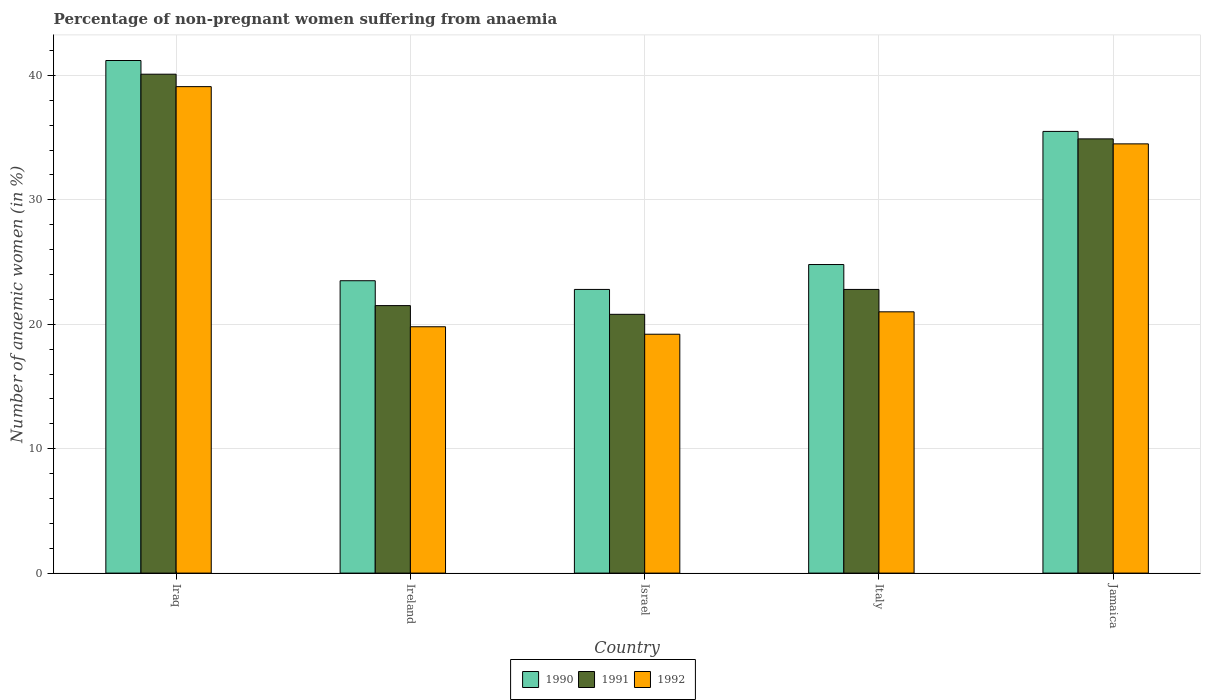How many different coloured bars are there?
Make the answer very short. 3. How many groups of bars are there?
Your answer should be compact. 5. Are the number of bars on each tick of the X-axis equal?
Keep it short and to the point. Yes. How many bars are there on the 1st tick from the left?
Provide a succinct answer. 3. What is the label of the 1st group of bars from the left?
Keep it short and to the point. Iraq. In how many cases, is the number of bars for a given country not equal to the number of legend labels?
Keep it short and to the point. 0. What is the percentage of non-pregnant women suffering from anaemia in 1991 in Israel?
Keep it short and to the point. 20.8. Across all countries, what is the maximum percentage of non-pregnant women suffering from anaemia in 1992?
Make the answer very short. 39.1. Across all countries, what is the minimum percentage of non-pregnant women suffering from anaemia in 1990?
Keep it short and to the point. 22.8. In which country was the percentage of non-pregnant women suffering from anaemia in 1991 maximum?
Your answer should be very brief. Iraq. In which country was the percentage of non-pregnant women suffering from anaemia in 1990 minimum?
Provide a short and direct response. Israel. What is the total percentage of non-pregnant women suffering from anaemia in 1992 in the graph?
Keep it short and to the point. 133.6. What is the difference between the percentage of non-pregnant women suffering from anaemia in 1992 in Iraq and that in Ireland?
Your answer should be very brief. 19.3. What is the difference between the percentage of non-pregnant women suffering from anaemia in 1992 in Israel and the percentage of non-pregnant women suffering from anaemia in 1990 in Italy?
Keep it short and to the point. -5.6. What is the average percentage of non-pregnant women suffering from anaemia in 1990 per country?
Provide a succinct answer. 29.56. What is the ratio of the percentage of non-pregnant women suffering from anaemia in 1990 in Ireland to that in Jamaica?
Offer a terse response. 0.66. Is the difference between the percentage of non-pregnant women suffering from anaemia in 1991 in Ireland and Italy greater than the difference between the percentage of non-pregnant women suffering from anaemia in 1992 in Ireland and Italy?
Offer a terse response. No. What is the difference between the highest and the second highest percentage of non-pregnant women suffering from anaemia in 1990?
Your answer should be very brief. -16.4. What is the difference between the highest and the lowest percentage of non-pregnant women suffering from anaemia in 1992?
Ensure brevity in your answer.  19.9. In how many countries, is the percentage of non-pregnant women suffering from anaemia in 1990 greater than the average percentage of non-pregnant women suffering from anaemia in 1990 taken over all countries?
Provide a succinct answer. 2. Is the sum of the percentage of non-pregnant women suffering from anaemia in 1991 in Israel and Jamaica greater than the maximum percentage of non-pregnant women suffering from anaemia in 1990 across all countries?
Provide a short and direct response. Yes. What does the 1st bar from the left in Iraq represents?
Ensure brevity in your answer.  1990. Is it the case that in every country, the sum of the percentage of non-pregnant women suffering from anaemia in 1991 and percentage of non-pregnant women suffering from anaemia in 1992 is greater than the percentage of non-pregnant women suffering from anaemia in 1990?
Your answer should be very brief. Yes. How many bars are there?
Your response must be concise. 15. Are all the bars in the graph horizontal?
Provide a short and direct response. No. Are the values on the major ticks of Y-axis written in scientific E-notation?
Offer a terse response. No. Does the graph contain any zero values?
Provide a succinct answer. No. Does the graph contain grids?
Your response must be concise. Yes. How many legend labels are there?
Offer a very short reply. 3. What is the title of the graph?
Give a very brief answer. Percentage of non-pregnant women suffering from anaemia. What is the label or title of the Y-axis?
Give a very brief answer. Number of anaemic women (in %). What is the Number of anaemic women (in %) of 1990 in Iraq?
Give a very brief answer. 41.2. What is the Number of anaemic women (in %) in 1991 in Iraq?
Offer a very short reply. 40.1. What is the Number of anaemic women (in %) of 1992 in Iraq?
Keep it short and to the point. 39.1. What is the Number of anaemic women (in %) in 1990 in Ireland?
Your response must be concise. 23.5. What is the Number of anaemic women (in %) in 1991 in Ireland?
Provide a short and direct response. 21.5. What is the Number of anaemic women (in %) in 1992 in Ireland?
Your answer should be compact. 19.8. What is the Number of anaemic women (in %) in 1990 in Israel?
Make the answer very short. 22.8. What is the Number of anaemic women (in %) of 1991 in Israel?
Ensure brevity in your answer.  20.8. What is the Number of anaemic women (in %) of 1992 in Israel?
Offer a very short reply. 19.2. What is the Number of anaemic women (in %) in 1990 in Italy?
Your response must be concise. 24.8. What is the Number of anaemic women (in %) of 1991 in Italy?
Ensure brevity in your answer.  22.8. What is the Number of anaemic women (in %) of 1990 in Jamaica?
Provide a succinct answer. 35.5. What is the Number of anaemic women (in %) of 1991 in Jamaica?
Offer a very short reply. 34.9. What is the Number of anaemic women (in %) in 1992 in Jamaica?
Provide a succinct answer. 34.5. Across all countries, what is the maximum Number of anaemic women (in %) of 1990?
Offer a very short reply. 41.2. Across all countries, what is the maximum Number of anaemic women (in %) in 1991?
Give a very brief answer. 40.1. Across all countries, what is the maximum Number of anaemic women (in %) in 1992?
Provide a succinct answer. 39.1. Across all countries, what is the minimum Number of anaemic women (in %) in 1990?
Keep it short and to the point. 22.8. Across all countries, what is the minimum Number of anaemic women (in %) in 1991?
Make the answer very short. 20.8. Across all countries, what is the minimum Number of anaemic women (in %) of 1992?
Provide a short and direct response. 19.2. What is the total Number of anaemic women (in %) of 1990 in the graph?
Make the answer very short. 147.8. What is the total Number of anaemic women (in %) in 1991 in the graph?
Provide a succinct answer. 140.1. What is the total Number of anaemic women (in %) in 1992 in the graph?
Your answer should be very brief. 133.6. What is the difference between the Number of anaemic women (in %) in 1991 in Iraq and that in Ireland?
Ensure brevity in your answer.  18.6. What is the difference between the Number of anaemic women (in %) of 1992 in Iraq and that in Ireland?
Your answer should be very brief. 19.3. What is the difference between the Number of anaemic women (in %) in 1990 in Iraq and that in Israel?
Your answer should be compact. 18.4. What is the difference between the Number of anaemic women (in %) of 1991 in Iraq and that in Israel?
Your answer should be very brief. 19.3. What is the difference between the Number of anaemic women (in %) in 1992 in Iraq and that in Israel?
Provide a succinct answer. 19.9. What is the difference between the Number of anaemic women (in %) of 1992 in Iraq and that in Italy?
Your answer should be compact. 18.1. What is the difference between the Number of anaemic women (in %) in 1991 in Iraq and that in Jamaica?
Your response must be concise. 5.2. What is the difference between the Number of anaemic women (in %) of 1992 in Iraq and that in Jamaica?
Make the answer very short. 4.6. What is the difference between the Number of anaemic women (in %) in 1990 in Ireland and that in Israel?
Offer a very short reply. 0.7. What is the difference between the Number of anaemic women (in %) of 1991 in Ireland and that in Israel?
Give a very brief answer. 0.7. What is the difference between the Number of anaemic women (in %) of 1990 in Ireland and that in Italy?
Your answer should be compact. -1.3. What is the difference between the Number of anaemic women (in %) in 1991 in Ireland and that in Italy?
Provide a succinct answer. -1.3. What is the difference between the Number of anaemic women (in %) of 1992 in Ireland and that in Italy?
Make the answer very short. -1.2. What is the difference between the Number of anaemic women (in %) of 1992 in Ireland and that in Jamaica?
Offer a very short reply. -14.7. What is the difference between the Number of anaemic women (in %) of 1990 in Israel and that in Italy?
Provide a short and direct response. -2. What is the difference between the Number of anaemic women (in %) of 1991 in Israel and that in Italy?
Make the answer very short. -2. What is the difference between the Number of anaemic women (in %) of 1992 in Israel and that in Italy?
Make the answer very short. -1.8. What is the difference between the Number of anaemic women (in %) of 1991 in Israel and that in Jamaica?
Give a very brief answer. -14.1. What is the difference between the Number of anaemic women (in %) of 1992 in Israel and that in Jamaica?
Your answer should be compact. -15.3. What is the difference between the Number of anaemic women (in %) in 1991 in Italy and that in Jamaica?
Your answer should be very brief. -12.1. What is the difference between the Number of anaemic women (in %) in 1992 in Italy and that in Jamaica?
Ensure brevity in your answer.  -13.5. What is the difference between the Number of anaemic women (in %) of 1990 in Iraq and the Number of anaemic women (in %) of 1992 in Ireland?
Provide a succinct answer. 21.4. What is the difference between the Number of anaemic women (in %) of 1991 in Iraq and the Number of anaemic women (in %) of 1992 in Ireland?
Offer a very short reply. 20.3. What is the difference between the Number of anaemic women (in %) of 1990 in Iraq and the Number of anaemic women (in %) of 1991 in Israel?
Give a very brief answer. 20.4. What is the difference between the Number of anaemic women (in %) in 1991 in Iraq and the Number of anaemic women (in %) in 1992 in Israel?
Provide a succinct answer. 20.9. What is the difference between the Number of anaemic women (in %) in 1990 in Iraq and the Number of anaemic women (in %) in 1992 in Italy?
Your answer should be compact. 20.2. What is the difference between the Number of anaemic women (in %) in 1990 in Iraq and the Number of anaemic women (in %) in 1991 in Jamaica?
Give a very brief answer. 6.3. What is the difference between the Number of anaemic women (in %) of 1990 in Ireland and the Number of anaemic women (in %) of 1991 in Israel?
Give a very brief answer. 2.7. What is the difference between the Number of anaemic women (in %) of 1990 in Ireland and the Number of anaemic women (in %) of 1992 in Israel?
Keep it short and to the point. 4.3. What is the difference between the Number of anaemic women (in %) in 1991 in Ireland and the Number of anaemic women (in %) in 1992 in Israel?
Provide a short and direct response. 2.3. What is the difference between the Number of anaemic women (in %) in 1990 in Ireland and the Number of anaemic women (in %) in 1991 in Jamaica?
Provide a short and direct response. -11.4. What is the difference between the Number of anaemic women (in %) of 1991 in Ireland and the Number of anaemic women (in %) of 1992 in Jamaica?
Make the answer very short. -13. What is the difference between the Number of anaemic women (in %) in 1990 in Israel and the Number of anaemic women (in %) in 1991 in Italy?
Give a very brief answer. 0. What is the difference between the Number of anaemic women (in %) of 1991 in Israel and the Number of anaemic women (in %) of 1992 in Italy?
Provide a succinct answer. -0.2. What is the difference between the Number of anaemic women (in %) in 1991 in Israel and the Number of anaemic women (in %) in 1992 in Jamaica?
Provide a short and direct response. -13.7. What is the difference between the Number of anaemic women (in %) of 1990 in Italy and the Number of anaemic women (in %) of 1991 in Jamaica?
Offer a very short reply. -10.1. What is the difference between the Number of anaemic women (in %) of 1990 in Italy and the Number of anaemic women (in %) of 1992 in Jamaica?
Ensure brevity in your answer.  -9.7. What is the average Number of anaemic women (in %) of 1990 per country?
Make the answer very short. 29.56. What is the average Number of anaemic women (in %) of 1991 per country?
Offer a terse response. 28.02. What is the average Number of anaemic women (in %) of 1992 per country?
Ensure brevity in your answer.  26.72. What is the difference between the Number of anaemic women (in %) in 1991 and Number of anaemic women (in %) in 1992 in Iraq?
Ensure brevity in your answer.  1. What is the difference between the Number of anaemic women (in %) in 1991 and Number of anaemic women (in %) in 1992 in Ireland?
Your response must be concise. 1.7. What is the difference between the Number of anaemic women (in %) of 1990 and Number of anaemic women (in %) of 1991 in Israel?
Provide a short and direct response. 2. What is the difference between the Number of anaemic women (in %) of 1990 and Number of anaemic women (in %) of 1992 in Israel?
Provide a succinct answer. 3.6. What is the difference between the Number of anaemic women (in %) of 1990 and Number of anaemic women (in %) of 1991 in Italy?
Your answer should be compact. 2. What is the difference between the Number of anaemic women (in %) in 1990 and Number of anaemic women (in %) in 1992 in Italy?
Your response must be concise. 3.8. What is the difference between the Number of anaemic women (in %) of 1990 and Number of anaemic women (in %) of 1991 in Jamaica?
Offer a very short reply. 0.6. What is the difference between the Number of anaemic women (in %) of 1990 and Number of anaemic women (in %) of 1992 in Jamaica?
Give a very brief answer. 1. What is the difference between the Number of anaemic women (in %) in 1991 and Number of anaemic women (in %) in 1992 in Jamaica?
Your answer should be compact. 0.4. What is the ratio of the Number of anaemic women (in %) in 1990 in Iraq to that in Ireland?
Ensure brevity in your answer.  1.75. What is the ratio of the Number of anaemic women (in %) in 1991 in Iraq to that in Ireland?
Your response must be concise. 1.87. What is the ratio of the Number of anaemic women (in %) of 1992 in Iraq to that in Ireland?
Provide a short and direct response. 1.97. What is the ratio of the Number of anaemic women (in %) of 1990 in Iraq to that in Israel?
Provide a succinct answer. 1.81. What is the ratio of the Number of anaemic women (in %) in 1991 in Iraq to that in Israel?
Your response must be concise. 1.93. What is the ratio of the Number of anaemic women (in %) in 1992 in Iraq to that in Israel?
Make the answer very short. 2.04. What is the ratio of the Number of anaemic women (in %) of 1990 in Iraq to that in Italy?
Offer a terse response. 1.66. What is the ratio of the Number of anaemic women (in %) of 1991 in Iraq to that in Italy?
Ensure brevity in your answer.  1.76. What is the ratio of the Number of anaemic women (in %) of 1992 in Iraq to that in Italy?
Ensure brevity in your answer.  1.86. What is the ratio of the Number of anaemic women (in %) of 1990 in Iraq to that in Jamaica?
Offer a terse response. 1.16. What is the ratio of the Number of anaemic women (in %) in 1991 in Iraq to that in Jamaica?
Keep it short and to the point. 1.15. What is the ratio of the Number of anaemic women (in %) in 1992 in Iraq to that in Jamaica?
Keep it short and to the point. 1.13. What is the ratio of the Number of anaemic women (in %) in 1990 in Ireland to that in Israel?
Make the answer very short. 1.03. What is the ratio of the Number of anaemic women (in %) in 1991 in Ireland to that in Israel?
Make the answer very short. 1.03. What is the ratio of the Number of anaemic women (in %) of 1992 in Ireland to that in Israel?
Your answer should be compact. 1.03. What is the ratio of the Number of anaemic women (in %) of 1990 in Ireland to that in Italy?
Provide a short and direct response. 0.95. What is the ratio of the Number of anaemic women (in %) in 1991 in Ireland to that in Italy?
Your response must be concise. 0.94. What is the ratio of the Number of anaemic women (in %) in 1992 in Ireland to that in Italy?
Your response must be concise. 0.94. What is the ratio of the Number of anaemic women (in %) of 1990 in Ireland to that in Jamaica?
Your answer should be very brief. 0.66. What is the ratio of the Number of anaemic women (in %) of 1991 in Ireland to that in Jamaica?
Give a very brief answer. 0.62. What is the ratio of the Number of anaemic women (in %) in 1992 in Ireland to that in Jamaica?
Offer a very short reply. 0.57. What is the ratio of the Number of anaemic women (in %) of 1990 in Israel to that in Italy?
Keep it short and to the point. 0.92. What is the ratio of the Number of anaemic women (in %) of 1991 in Israel to that in Italy?
Ensure brevity in your answer.  0.91. What is the ratio of the Number of anaemic women (in %) of 1992 in Israel to that in Italy?
Keep it short and to the point. 0.91. What is the ratio of the Number of anaemic women (in %) of 1990 in Israel to that in Jamaica?
Your response must be concise. 0.64. What is the ratio of the Number of anaemic women (in %) of 1991 in Israel to that in Jamaica?
Ensure brevity in your answer.  0.6. What is the ratio of the Number of anaemic women (in %) in 1992 in Israel to that in Jamaica?
Give a very brief answer. 0.56. What is the ratio of the Number of anaemic women (in %) of 1990 in Italy to that in Jamaica?
Offer a very short reply. 0.7. What is the ratio of the Number of anaemic women (in %) in 1991 in Italy to that in Jamaica?
Your response must be concise. 0.65. What is the ratio of the Number of anaemic women (in %) in 1992 in Italy to that in Jamaica?
Your answer should be compact. 0.61. What is the difference between the highest and the lowest Number of anaemic women (in %) of 1991?
Your answer should be very brief. 19.3. 